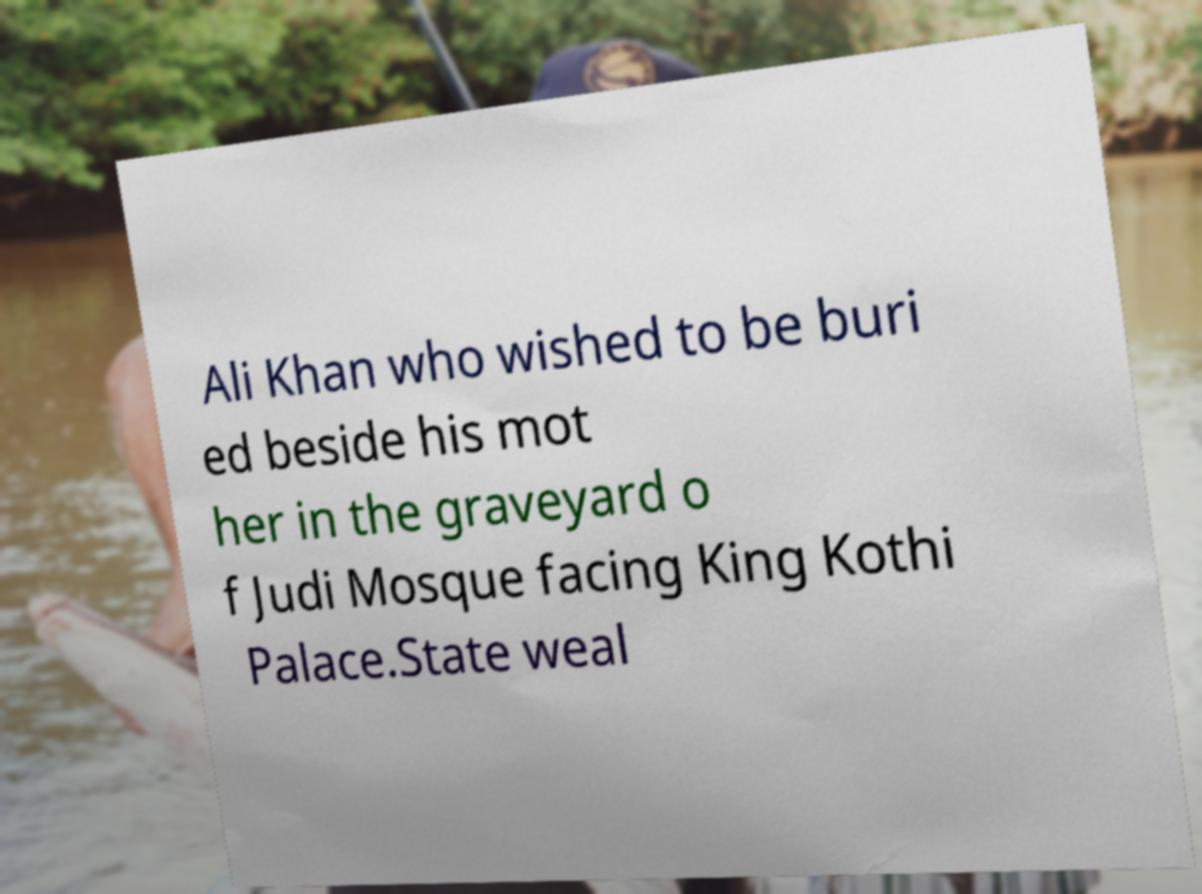Can you accurately transcribe the text from the provided image for me? Ali Khan who wished to be buri ed beside his mot her in the graveyard o f Judi Mosque facing King Kothi Palace.State weal 